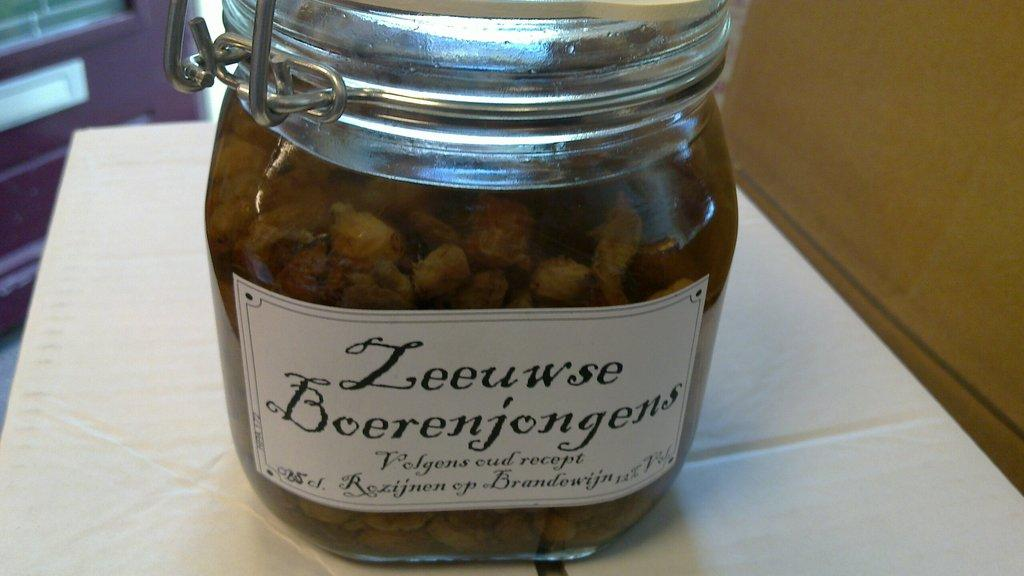<image>
Relay a brief, clear account of the picture shown. A clear jar with a label saying Zeeuwse Boerenjongens. 